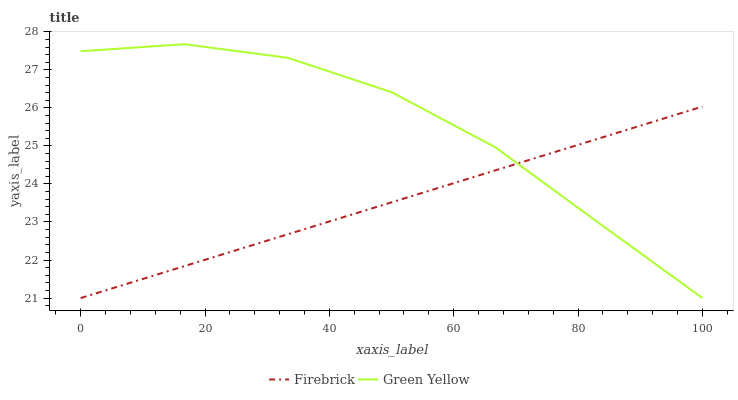Does Firebrick have the minimum area under the curve?
Answer yes or no. Yes. Does Green Yellow have the maximum area under the curve?
Answer yes or no. Yes. Does Green Yellow have the minimum area under the curve?
Answer yes or no. No. Is Firebrick the smoothest?
Answer yes or no. Yes. Is Green Yellow the roughest?
Answer yes or no. Yes. Is Green Yellow the smoothest?
Answer yes or no. No. Does Firebrick have the lowest value?
Answer yes or no. Yes. Does Green Yellow have the highest value?
Answer yes or no. Yes. Does Green Yellow intersect Firebrick?
Answer yes or no. Yes. Is Green Yellow less than Firebrick?
Answer yes or no. No. Is Green Yellow greater than Firebrick?
Answer yes or no. No. 